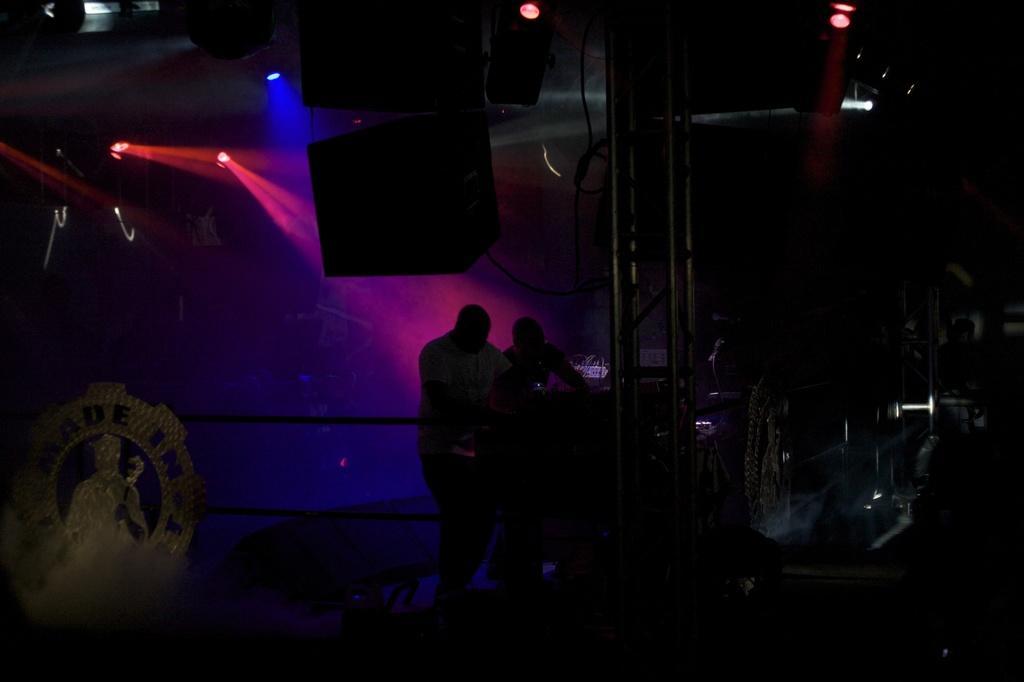Describe this image in one or two sentences. In the middle of the picture, we see two people are standing. In front of them, we see an iron pillar. In the left bottom of the picture, we see an award or a shield. At the top, we see the lights and black color boxes. In the background, it is black in color. This picture is clicked in the dark. 